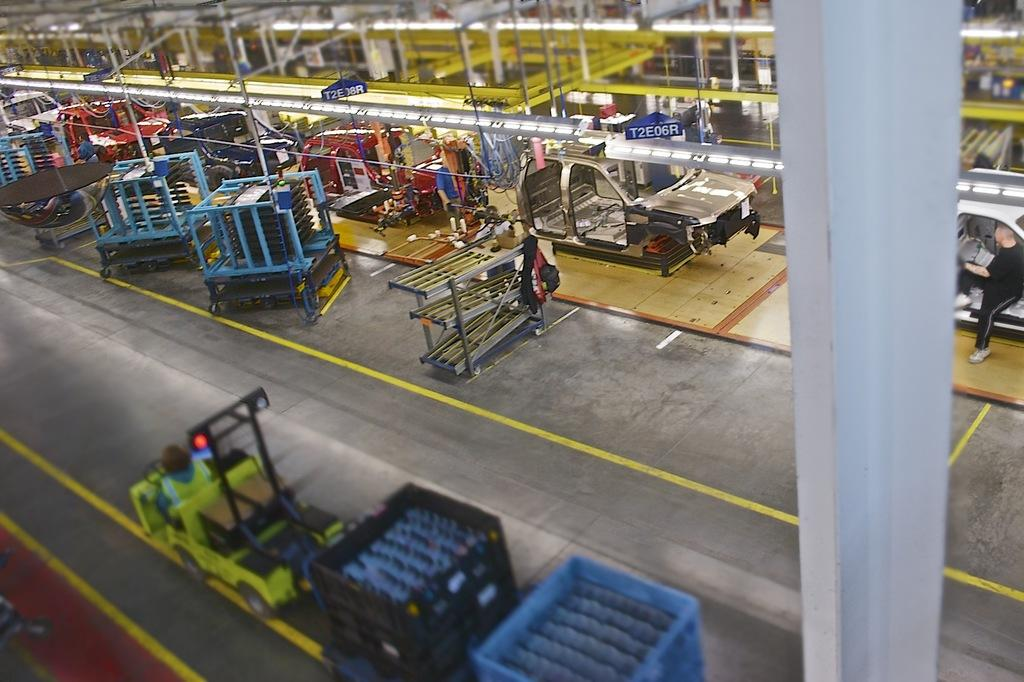What types of objects are present in the image? There are vehicles and vehicle parts in the image. What can be said about the colors of the vehicles and parts? The vehicles and parts are in various colors, including green, black, blue, red, and white. Are there any other objects present in the image besides vehicles and parts? Yes, there is a blue color board and an iron pole in the image. What type of cloud can be seen in the image? There are no clouds present in the image; it features vehicles, vehicle parts, a blue color board, and an iron pole. Can you describe the top of the tallest vehicle in the image? The image does not provide enough detail to describe the top of any specific vehicle. 